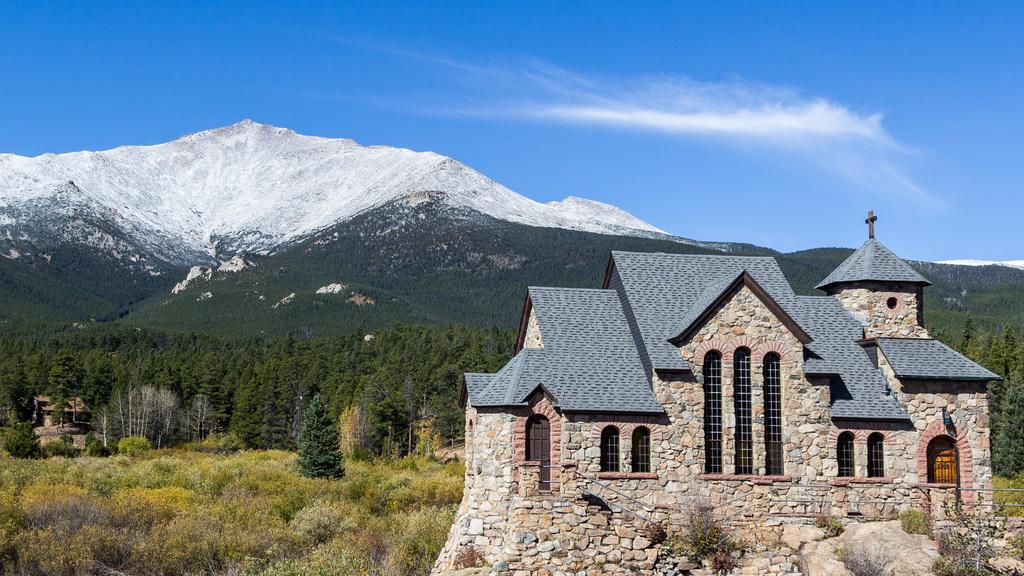What type of structure is visible in the image? There is a house structure in the image. What symbol can be seen in the foreground area of the image? There is a plus sign in the foreground area of the image. What type of vegetation is visible in the background of the image? There are trees in the background of the image. What geographical feature is visible in the background of the image? There are mountains in the background of the image. What is visible in the sky in the background of the image? The sky is visible in the background of the image. What type of brake system is installed on the house in the image? There is no brake system mentioned or visible in the image; it features a house structure, a plus sign, trees, mountains, and the sky. 